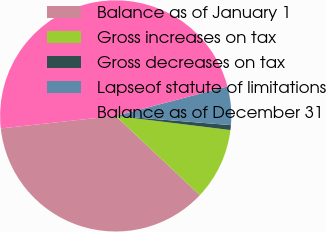<chart> <loc_0><loc_0><loc_500><loc_500><pie_chart><fcel>Balance as of January 1<fcel>Gross increases on tax<fcel>Gross decreases on tax<fcel>Lapseof statute of limitations<fcel>Balance as of December 31<nl><fcel>36.25%<fcel>10.07%<fcel>0.68%<fcel>5.38%<fcel>47.62%<nl></chart> 